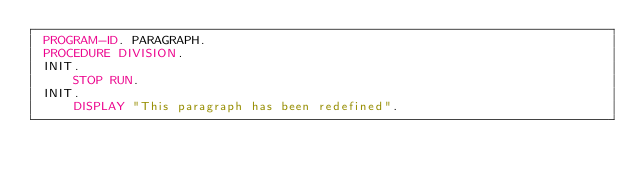Convert code to text. <code><loc_0><loc_0><loc_500><loc_500><_COBOL_> PROGRAM-ID. PARAGRAPH.
 PROCEDURE DIVISION.
 INIT.
     STOP RUN.
 INIT.
     DISPLAY "This paragraph has been redefined".</code> 